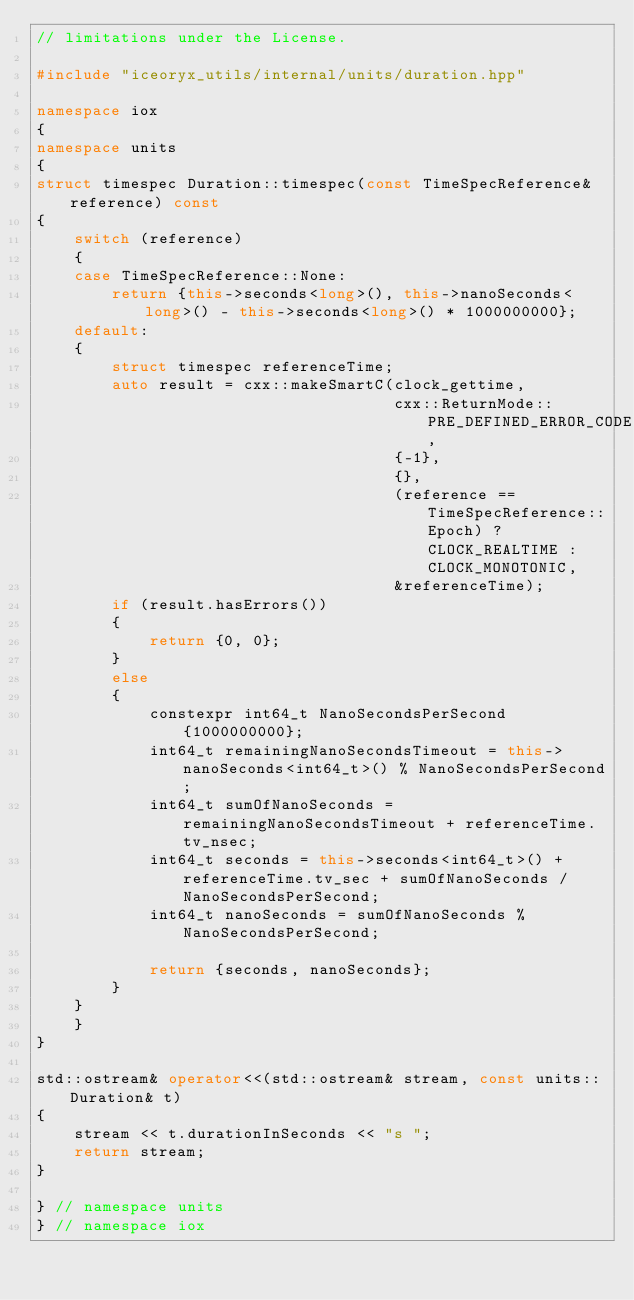Convert code to text. <code><loc_0><loc_0><loc_500><loc_500><_C++_>// limitations under the License.

#include "iceoryx_utils/internal/units/duration.hpp"

namespace iox
{
namespace units
{
struct timespec Duration::timespec(const TimeSpecReference& reference) const
{
    switch (reference)
    {
    case TimeSpecReference::None:
        return {this->seconds<long>(), this->nanoSeconds<long>() - this->seconds<long>() * 1000000000};
    default:
    {
        struct timespec referenceTime;
        auto result = cxx::makeSmartC(clock_gettime,
                                      cxx::ReturnMode::PRE_DEFINED_ERROR_CODE,
                                      {-1},
                                      {},
                                      (reference == TimeSpecReference::Epoch) ? CLOCK_REALTIME : CLOCK_MONOTONIC,
                                      &referenceTime);
        if (result.hasErrors())
        {
            return {0, 0};
        }
        else
        {
            constexpr int64_t NanoSecondsPerSecond{1000000000};
            int64_t remainingNanoSecondsTimeout = this->nanoSeconds<int64_t>() % NanoSecondsPerSecond;
            int64_t sumOfNanoSeconds = remainingNanoSecondsTimeout + referenceTime.tv_nsec;
            int64_t seconds = this->seconds<int64_t>() + referenceTime.tv_sec + sumOfNanoSeconds / NanoSecondsPerSecond;
            int64_t nanoSeconds = sumOfNanoSeconds % NanoSecondsPerSecond;

            return {seconds, nanoSeconds};
        }
    }
    }
}

std::ostream& operator<<(std::ostream& stream, const units::Duration& t)
{
    stream << t.durationInSeconds << "s ";
    return stream;
}

} // namespace units
} // namespace iox
</code> 